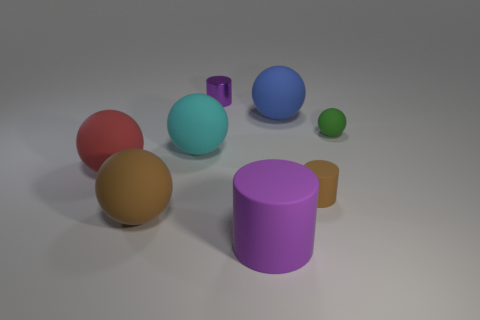Subtract all green spheres. How many spheres are left? 4 Subtract all green matte spheres. How many spheres are left? 4 Subtract 2 spheres. How many spheres are left? 3 Add 1 brown things. How many objects exist? 9 Subtract all brown balls. Subtract all gray cubes. How many balls are left? 4 Subtract all cylinders. How many objects are left? 5 Subtract all large purple matte things. Subtract all red things. How many objects are left? 6 Add 8 tiny brown rubber cylinders. How many tiny brown rubber cylinders are left? 9 Add 2 cylinders. How many cylinders exist? 5 Subtract 1 brown cylinders. How many objects are left? 7 